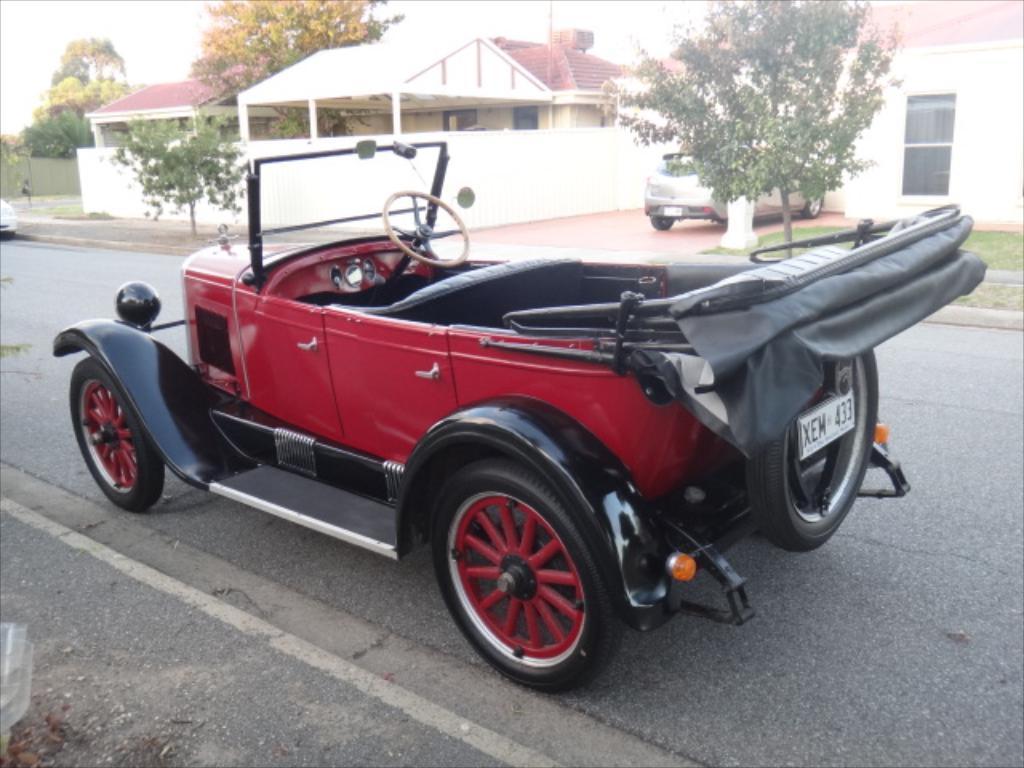In one or two sentences, can you explain what this image depicts? This is an outside view. Here I can see a red color vehicle on the road. On the left side there is a car. In the background there are few buildings and trees. In front of this building there is a car. At the top of the image I can see the sky. 